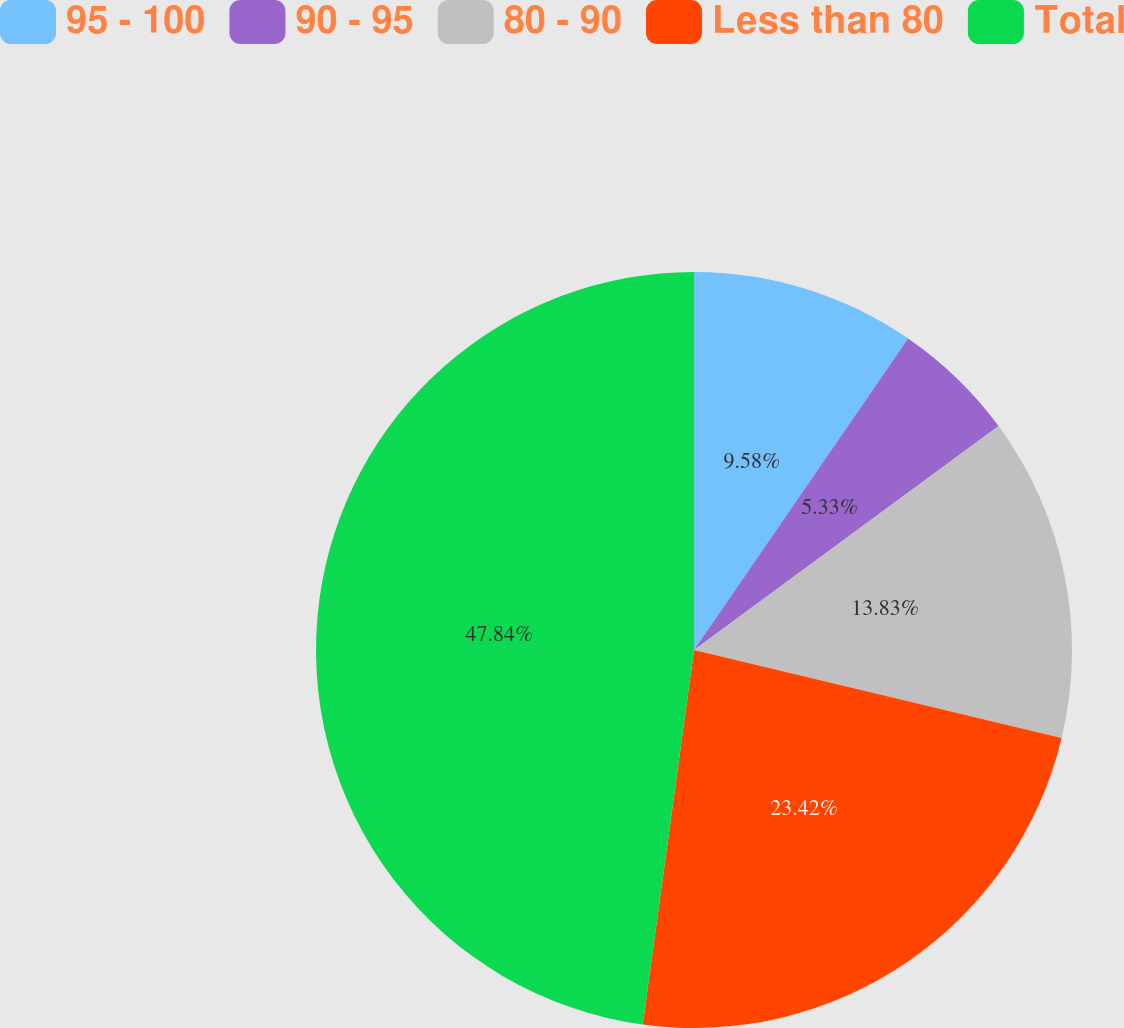<chart> <loc_0><loc_0><loc_500><loc_500><pie_chart><fcel>95 - 100<fcel>90 - 95<fcel>80 - 90<fcel>Less than 80<fcel>Total<nl><fcel>9.58%<fcel>5.33%<fcel>13.83%<fcel>23.42%<fcel>47.83%<nl></chart> 